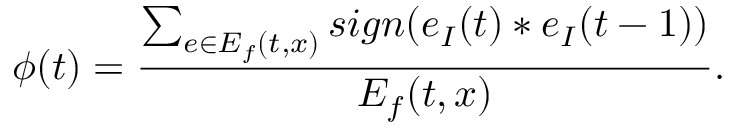<formula> <loc_0><loc_0><loc_500><loc_500>\phi ( t ) = \frac { \sum _ { e \in E _ { f } ( t , x ) } s i g n ( e _ { I } ( t ) * e _ { I } ( t - 1 ) ) } { E _ { f } ( t , x ) } .</formula> 